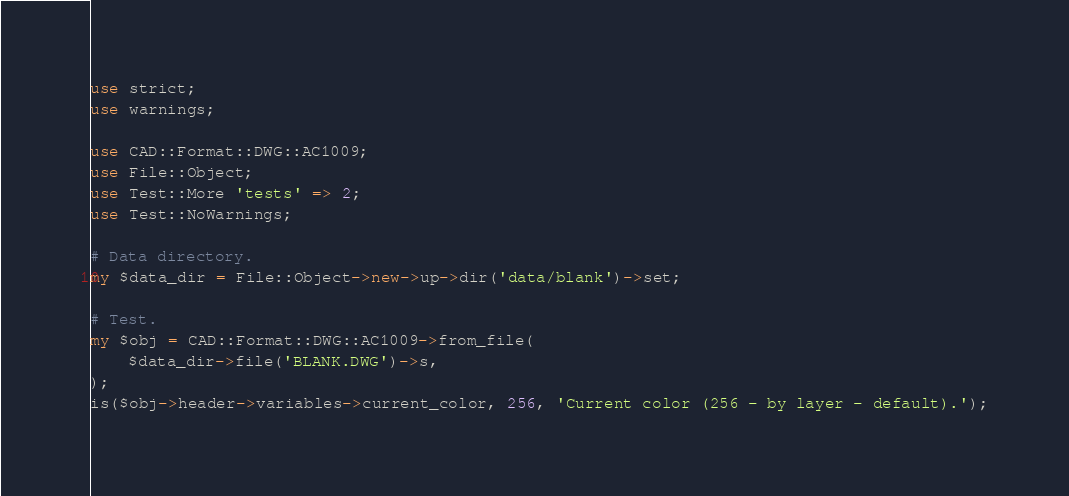Convert code to text. <code><loc_0><loc_0><loc_500><loc_500><_Perl_>use strict;
use warnings;

use CAD::Format::DWG::AC1009;
use File::Object;
use Test::More 'tests' => 2;
use Test::NoWarnings;

# Data directory.
my $data_dir = File::Object->new->up->dir('data/blank')->set;

# Test.
my $obj = CAD::Format::DWG::AC1009->from_file(
	$data_dir->file('BLANK.DWG')->s,
);
is($obj->header->variables->current_color, 256, 'Current color (256 - by layer - default).');
</code> 